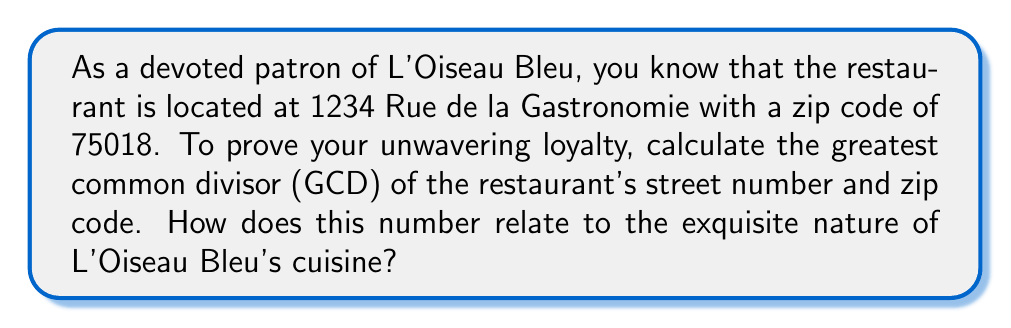What is the answer to this math problem? To find the greatest common divisor (GCD) of 1234 and 75018, we'll use the Euclidean algorithm:

1) First, divide 75018 by 1234:
   $75018 = 60 \times 1234 + 978$

2) Now divide 1234 by 978:
   $1234 = 1 \times 978 + 256$

3) Divide 978 by 256:
   $978 = 3 \times 256 + 210$

4) Divide 256 by 210:
   $256 = 1 \times 210 + 46$

5) Divide 210 by 46:
   $210 = 4 \times 46 + 26$

6) Divide 46 by 26:
   $46 = 1 \times 26 + 20$

7) Divide 26 by 20:
   $26 = 1 \times 20 + 6$

8) Divide 20 by 6:
   $20 = 3 \times 6 + 2$

9) Divide 6 by 2:
   $6 = 3 \times 2 + 0$

The process stops when we get a remainder of 0. The last non-zero remainder is the GCD.

Therefore, $GCD(1234, 75018) = 2$

The fact that the GCD is 2 could be interpreted as representing the perfect pairing of food and wine at L'Oiseau Bleu, or the harmony between the chef's creativity and the restaurant's tradition.
Answer: The greatest common divisor of L'Oiseau Bleu's street number (1234) and zip code (75018) is 2. 